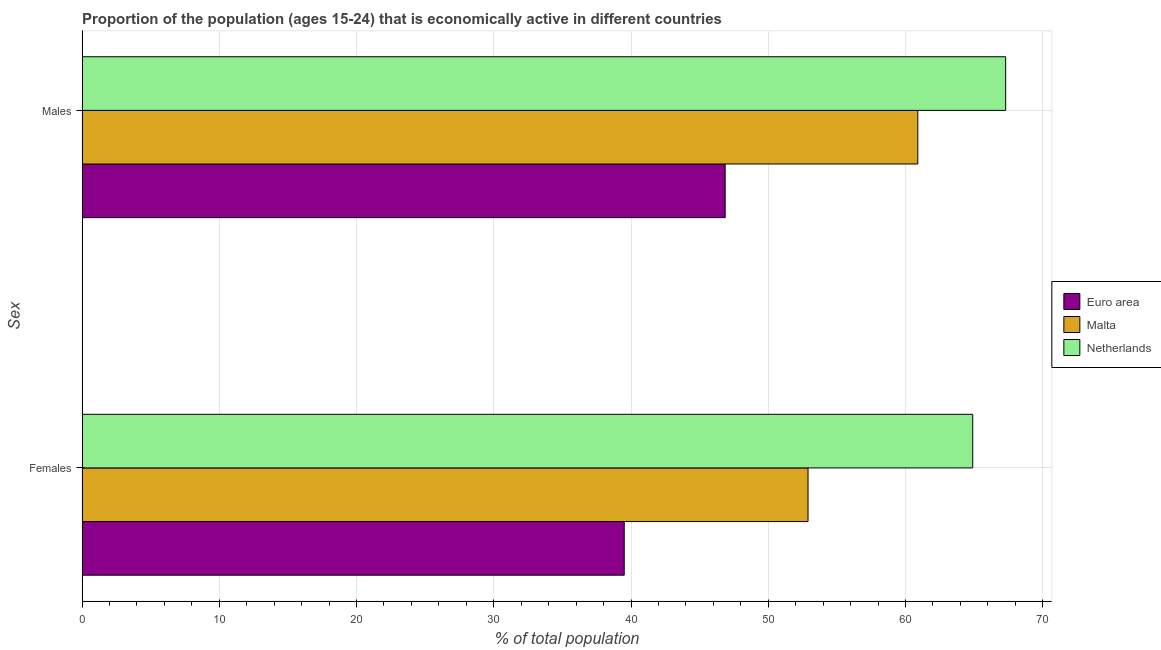How many different coloured bars are there?
Provide a succinct answer. 3. Are the number of bars on each tick of the Y-axis equal?
Provide a succinct answer. Yes. How many bars are there on the 1st tick from the top?
Give a very brief answer. 3. How many bars are there on the 2nd tick from the bottom?
Keep it short and to the point. 3. What is the label of the 1st group of bars from the top?
Provide a succinct answer. Males. What is the percentage of economically active male population in Malta?
Keep it short and to the point. 60.9. Across all countries, what is the maximum percentage of economically active female population?
Ensure brevity in your answer.  64.9. Across all countries, what is the minimum percentage of economically active male population?
Offer a very short reply. 46.86. In which country was the percentage of economically active male population maximum?
Offer a terse response. Netherlands. In which country was the percentage of economically active male population minimum?
Provide a short and direct response. Euro area. What is the total percentage of economically active male population in the graph?
Your answer should be very brief. 175.06. What is the difference between the percentage of economically active male population in Euro area and that in Netherlands?
Provide a short and direct response. -20.44. What is the difference between the percentage of economically active male population in Netherlands and the percentage of economically active female population in Euro area?
Ensure brevity in your answer.  27.79. What is the average percentage of economically active female population per country?
Your answer should be very brief. 52.44. What is the difference between the percentage of economically active male population and percentage of economically active female population in Malta?
Make the answer very short. 8. In how many countries, is the percentage of economically active female population greater than 66 %?
Ensure brevity in your answer.  0. What is the ratio of the percentage of economically active male population in Euro area to that in Malta?
Ensure brevity in your answer.  0.77. Is the percentage of economically active male population in Malta less than that in Euro area?
Provide a short and direct response. No. In how many countries, is the percentage of economically active male population greater than the average percentage of economically active male population taken over all countries?
Give a very brief answer. 2. What does the 1st bar from the top in Males represents?
Ensure brevity in your answer.  Netherlands. What does the 2nd bar from the bottom in Females represents?
Your answer should be compact. Malta. How many bars are there?
Give a very brief answer. 6. Are all the bars in the graph horizontal?
Offer a very short reply. Yes. Does the graph contain any zero values?
Your response must be concise. No. How many legend labels are there?
Provide a succinct answer. 3. What is the title of the graph?
Provide a succinct answer. Proportion of the population (ages 15-24) that is economically active in different countries. Does "Europe(all income levels)" appear as one of the legend labels in the graph?
Provide a succinct answer. No. What is the label or title of the X-axis?
Your answer should be compact. % of total population. What is the label or title of the Y-axis?
Keep it short and to the point. Sex. What is the % of total population of Euro area in Females?
Give a very brief answer. 39.51. What is the % of total population in Malta in Females?
Provide a short and direct response. 52.9. What is the % of total population in Netherlands in Females?
Keep it short and to the point. 64.9. What is the % of total population of Euro area in Males?
Give a very brief answer. 46.86. What is the % of total population of Malta in Males?
Ensure brevity in your answer.  60.9. What is the % of total population of Netherlands in Males?
Your response must be concise. 67.3. Across all Sex, what is the maximum % of total population in Euro area?
Your answer should be compact. 46.86. Across all Sex, what is the maximum % of total population in Malta?
Provide a short and direct response. 60.9. Across all Sex, what is the maximum % of total population in Netherlands?
Your response must be concise. 67.3. Across all Sex, what is the minimum % of total population of Euro area?
Provide a short and direct response. 39.51. Across all Sex, what is the minimum % of total population of Malta?
Provide a succinct answer. 52.9. Across all Sex, what is the minimum % of total population in Netherlands?
Keep it short and to the point. 64.9. What is the total % of total population in Euro area in the graph?
Provide a short and direct response. 86.37. What is the total % of total population of Malta in the graph?
Keep it short and to the point. 113.8. What is the total % of total population in Netherlands in the graph?
Your response must be concise. 132.2. What is the difference between the % of total population in Euro area in Females and that in Males?
Ensure brevity in your answer.  -7.36. What is the difference between the % of total population in Netherlands in Females and that in Males?
Provide a succinct answer. -2.4. What is the difference between the % of total population in Euro area in Females and the % of total population in Malta in Males?
Provide a short and direct response. -21.39. What is the difference between the % of total population of Euro area in Females and the % of total population of Netherlands in Males?
Offer a very short reply. -27.79. What is the difference between the % of total population in Malta in Females and the % of total population in Netherlands in Males?
Offer a terse response. -14.4. What is the average % of total population in Euro area per Sex?
Offer a terse response. 43.19. What is the average % of total population in Malta per Sex?
Make the answer very short. 56.9. What is the average % of total population in Netherlands per Sex?
Your response must be concise. 66.1. What is the difference between the % of total population of Euro area and % of total population of Malta in Females?
Offer a very short reply. -13.39. What is the difference between the % of total population of Euro area and % of total population of Netherlands in Females?
Ensure brevity in your answer.  -25.39. What is the difference between the % of total population of Malta and % of total population of Netherlands in Females?
Keep it short and to the point. -12. What is the difference between the % of total population in Euro area and % of total population in Malta in Males?
Keep it short and to the point. -14.04. What is the difference between the % of total population in Euro area and % of total population in Netherlands in Males?
Offer a very short reply. -20.44. What is the difference between the % of total population in Malta and % of total population in Netherlands in Males?
Keep it short and to the point. -6.4. What is the ratio of the % of total population of Euro area in Females to that in Males?
Offer a very short reply. 0.84. What is the ratio of the % of total population of Malta in Females to that in Males?
Provide a succinct answer. 0.87. What is the ratio of the % of total population in Netherlands in Females to that in Males?
Ensure brevity in your answer.  0.96. What is the difference between the highest and the second highest % of total population of Euro area?
Give a very brief answer. 7.36. What is the difference between the highest and the second highest % of total population of Malta?
Provide a short and direct response. 8. What is the difference between the highest and the second highest % of total population in Netherlands?
Provide a short and direct response. 2.4. What is the difference between the highest and the lowest % of total population in Euro area?
Make the answer very short. 7.36. What is the difference between the highest and the lowest % of total population in Netherlands?
Your response must be concise. 2.4. 